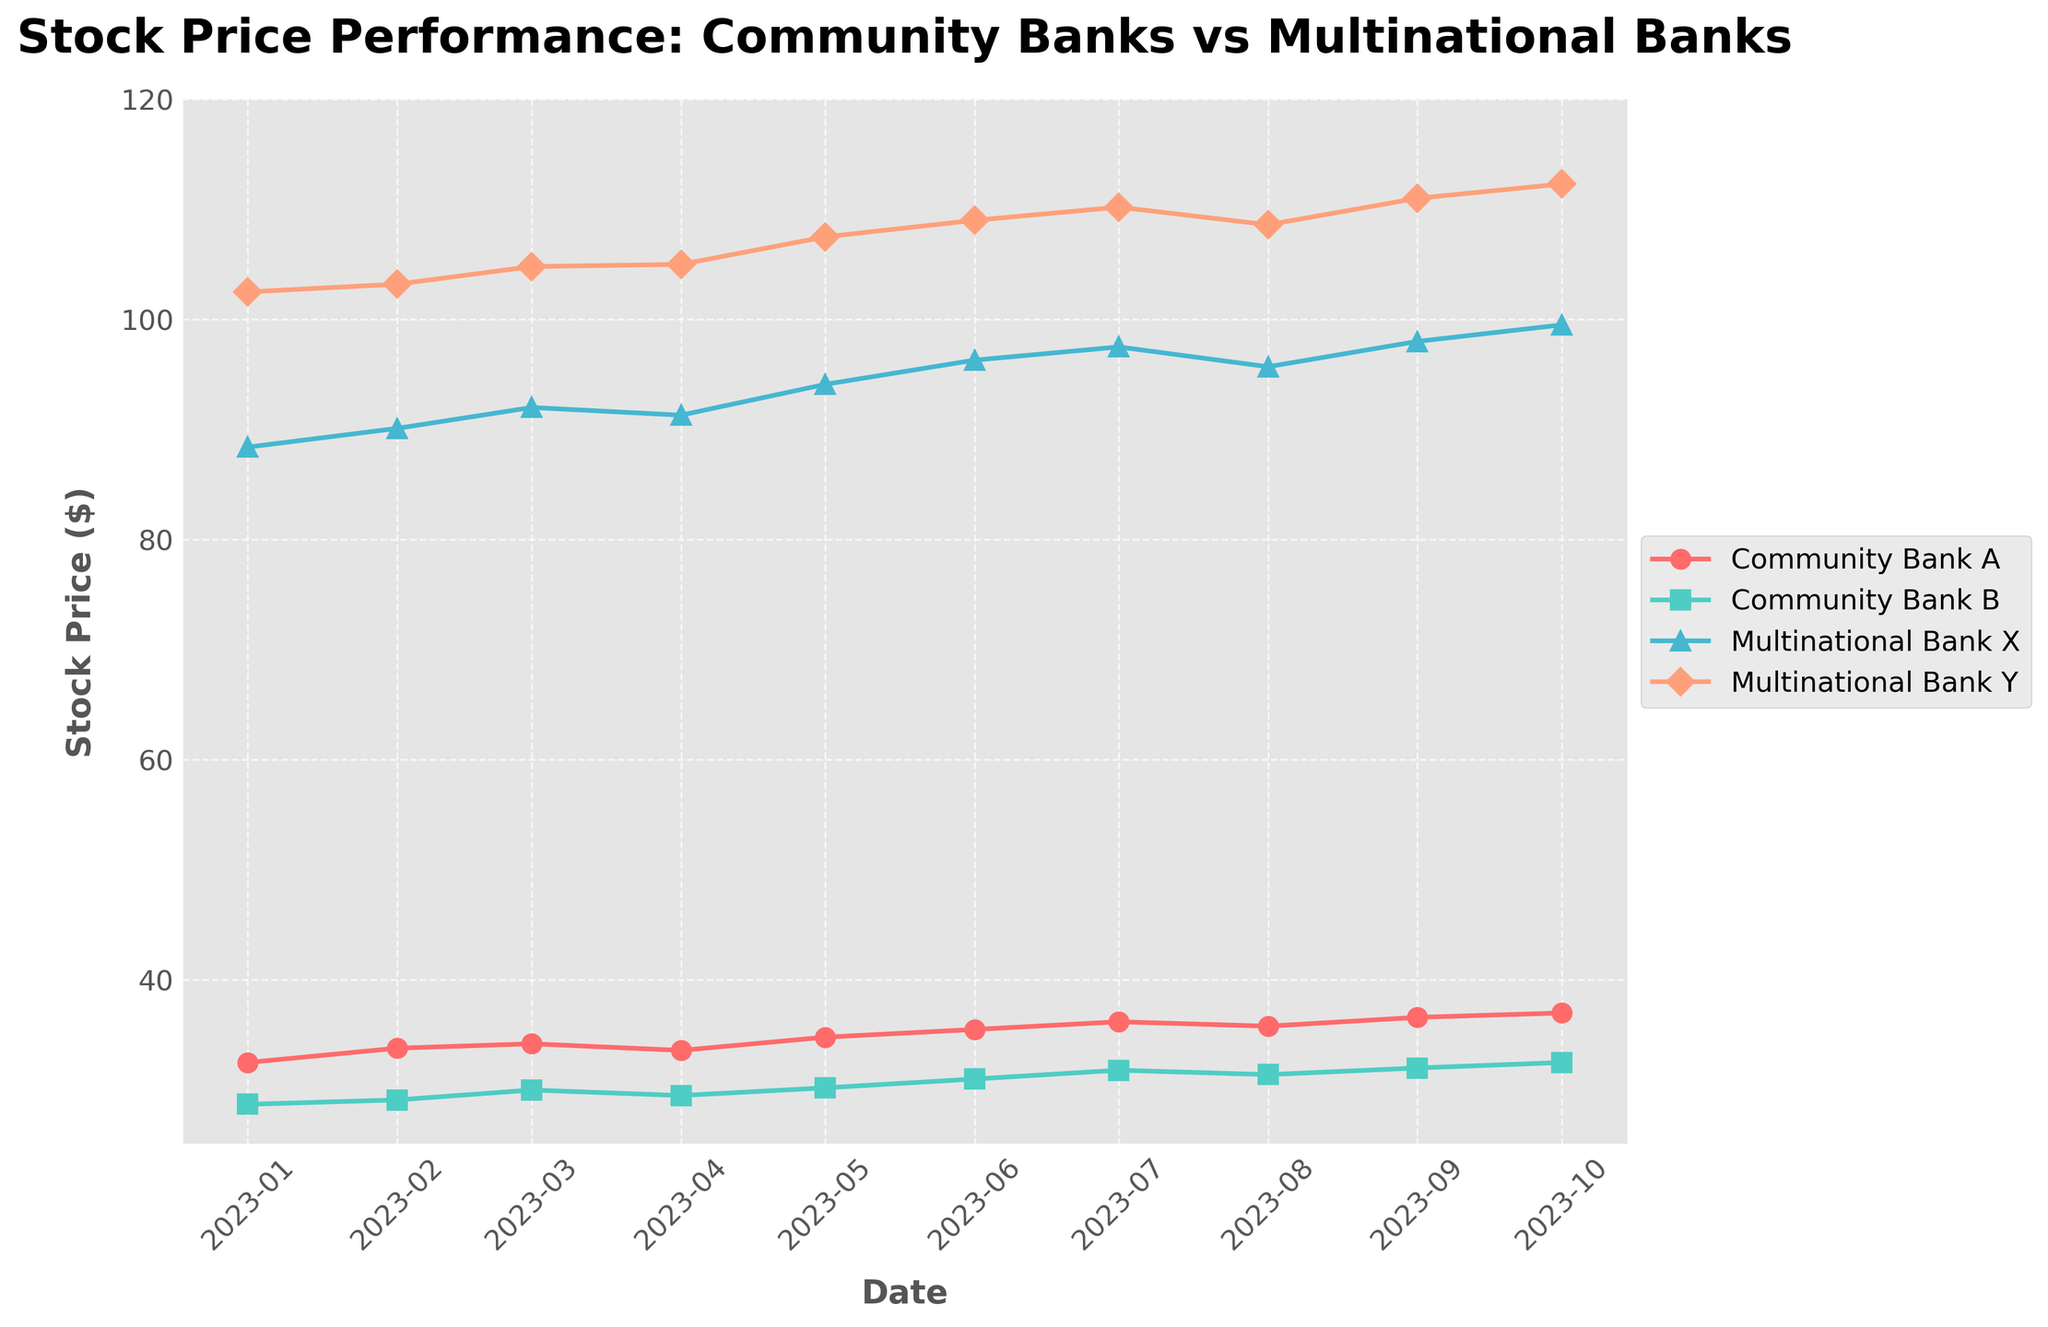What is the title of the figure? The title of the figure is prominently displayed at the top, providing information on what the plot represents. From the figure, we can see it is titled 'Stock Price Performance: Community Banks vs Multinational Banks'.
Answer: Stock Price Performance: Community Banks vs Multinational Banks How many data points are there for each bank? By counting the markers on each of the lines representing the banks, we can see there are 10 data points for each bank (one for each month from January to October 2023).
Answer: 10 Which bank had the highest stock price in October 2023? Looking at the last data point (October 2023) on the x-axis, the highest stock price can be identified from the y-axis values. Multinational Bank Y has the highest stock price of $112.3 at this point.
Answer: Multinational Bank Y Did Community Bank A ever have a lower stock price than Community Bank B in this period? By observing the two lines representing Community Bank A and Community Bank B, we can compare their stock prices for each month. Community Bank A's stock price is higher than Community Bank B's over the entire period.
Answer: No On which date did Community Bank A and Multinational Bank X have the same stock price trend? We need to find a period when the slopes of the lines are parallel, meaning they have the same trend. Both lines rise consistently over the period but don't align exactly at any specific point within the plot.
Answer: None What is the average stock price of Community Bank A between January 2023 and October 2023? Sum the stock prices of Community Bank A for each month and divide by the number of months: (32.5 + 33.8 + 34.2 + 33.6 + 34.8 + 35.5 + 36.2 + 35.8 + 36.6 + 37.0) / 10 = 35.0.
Answer: 35.0 By how much did the stock price of Multinational Bank Y change from January 2023 to October 2023? Subtract the January 2023 stock price of Multinational Bank Y from the October 2023 stock price: 112.3 - 102.5 = 9.8.
Answer: 9.8 Which bank showed the most consistent growth over the months? By examining the smoothness and slope consistency of each line, Multinational Bank Y shows the most consistent upward trajectory.
Answer: Multinational Bank Y Which bank had the most volatile stock prices within this period? Volatility can be assessed by the variability and number of fluctuations in the plotted line. Community Bank A has several ups and downs, indicating higher volatility compared to the other banks.
Answer: Community Bank A Between July and August 2023, which bank's stock price decreased? Observing the slope of lines between these two points, Community Bank A and Multinational Bank X show a decrease in stock price in this period.
Answer: Community Bank A and Multinational Bank X 